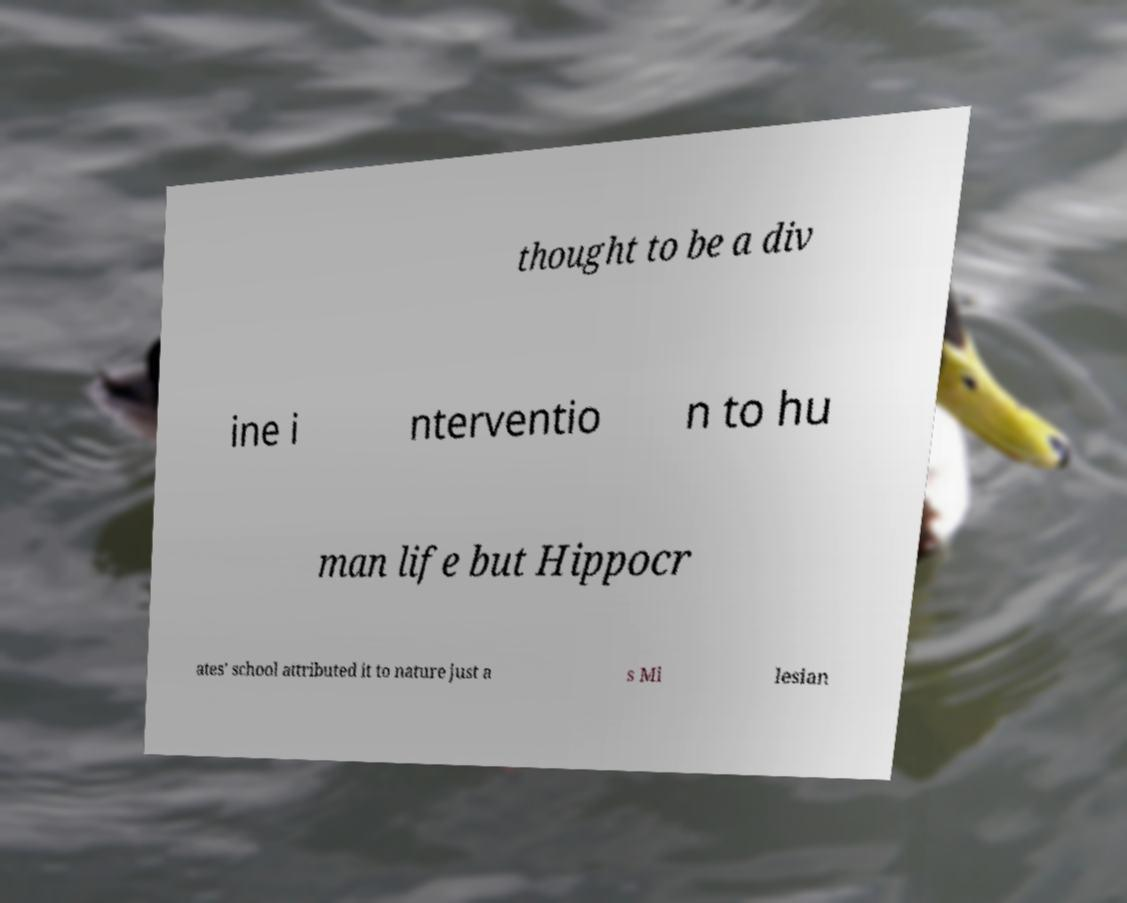I need the written content from this picture converted into text. Can you do that? thought to be a div ine i nterventio n to hu man life but Hippocr ates' school attributed it to nature just a s Mi lesian 